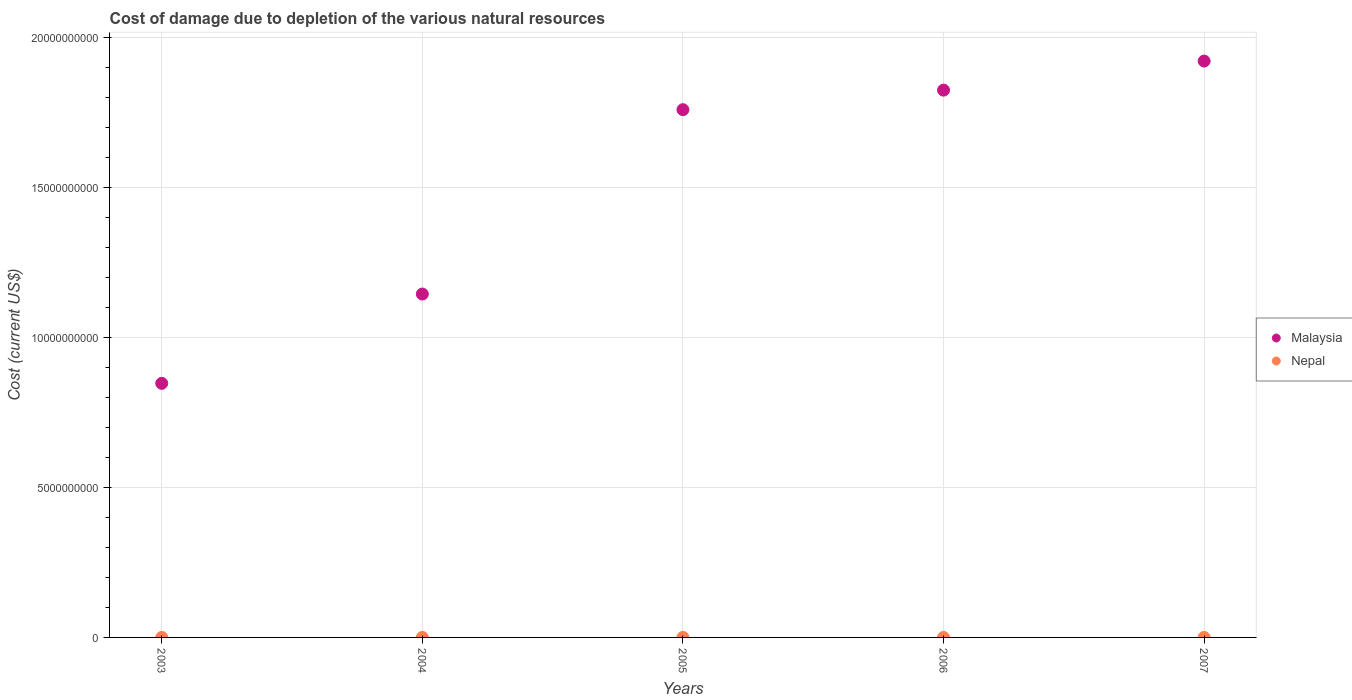How many different coloured dotlines are there?
Provide a succinct answer. 2. Is the number of dotlines equal to the number of legend labels?
Your response must be concise. Yes. What is the cost of damage caused due to the depletion of various natural resources in Malaysia in 2005?
Your answer should be compact. 1.76e+1. Across all years, what is the maximum cost of damage caused due to the depletion of various natural resources in Malaysia?
Your answer should be compact. 1.92e+1. Across all years, what is the minimum cost of damage caused due to the depletion of various natural resources in Malaysia?
Offer a terse response. 8.47e+09. In which year was the cost of damage caused due to the depletion of various natural resources in Malaysia maximum?
Provide a short and direct response. 2007. In which year was the cost of damage caused due to the depletion of various natural resources in Nepal minimum?
Make the answer very short. 2003. What is the total cost of damage caused due to the depletion of various natural resources in Nepal in the graph?
Your answer should be compact. 9.70e+05. What is the difference between the cost of damage caused due to the depletion of various natural resources in Nepal in 2004 and that in 2007?
Offer a terse response. -1.39e+05. What is the difference between the cost of damage caused due to the depletion of various natural resources in Malaysia in 2005 and the cost of damage caused due to the depletion of various natural resources in Nepal in 2007?
Offer a very short reply. 1.76e+1. What is the average cost of damage caused due to the depletion of various natural resources in Malaysia per year?
Make the answer very short. 1.50e+1. In the year 2007, what is the difference between the cost of damage caused due to the depletion of various natural resources in Malaysia and cost of damage caused due to the depletion of various natural resources in Nepal?
Offer a very short reply. 1.92e+1. What is the ratio of the cost of damage caused due to the depletion of various natural resources in Malaysia in 2004 to that in 2005?
Keep it short and to the point. 0.65. Is the difference between the cost of damage caused due to the depletion of various natural resources in Malaysia in 2003 and 2004 greater than the difference between the cost of damage caused due to the depletion of various natural resources in Nepal in 2003 and 2004?
Offer a terse response. No. What is the difference between the highest and the second highest cost of damage caused due to the depletion of various natural resources in Nepal?
Provide a succinct answer. 1.12e+04. What is the difference between the highest and the lowest cost of damage caused due to the depletion of various natural resources in Nepal?
Your answer should be compact. 2.63e+05. Does the cost of damage caused due to the depletion of various natural resources in Nepal monotonically increase over the years?
Offer a very short reply. No. Is the cost of damage caused due to the depletion of various natural resources in Nepal strictly greater than the cost of damage caused due to the depletion of various natural resources in Malaysia over the years?
Your response must be concise. No. Is the cost of damage caused due to the depletion of various natural resources in Malaysia strictly less than the cost of damage caused due to the depletion of various natural resources in Nepal over the years?
Offer a very short reply. No. How many dotlines are there?
Make the answer very short. 2. How many years are there in the graph?
Provide a short and direct response. 5. What is the difference between two consecutive major ticks on the Y-axis?
Make the answer very short. 5.00e+09. Are the values on the major ticks of Y-axis written in scientific E-notation?
Your response must be concise. No. Does the graph contain any zero values?
Offer a terse response. No. Does the graph contain grids?
Make the answer very short. Yes. How many legend labels are there?
Your response must be concise. 2. How are the legend labels stacked?
Your answer should be very brief. Vertical. What is the title of the graph?
Offer a terse response. Cost of damage due to depletion of the various natural resources. Does "Malta" appear as one of the legend labels in the graph?
Make the answer very short. No. What is the label or title of the X-axis?
Your response must be concise. Years. What is the label or title of the Y-axis?
Give a very brief answer. Cost (current US$). What is the Cost (current US$) of Malaysia in 2003?
Keep it short and to the point. 8.47e+09. What is the Cost (current US$) in Nepal in 2003?
Your response must be concise. 4.26e+04. What is the Cost (current US$) of Malaysia in 2004?
Your response must be concise. 1.14e+1. What is the Cost (current US$) of Nepal in 2004?
Offer a terse response. 1.67e+05. What is the Cost (current US$) of Malaysia in 2005?
Ensure brevity in your answer.  1.76e+1. What is the Cost (current US$) of Nepal in 2005?
Provide a short and direct response. 1.60e+05. What is the Cost (current US$) in Malaysia in 2006?
Provide a succinct answer. 1.82e+1. What is the Cost (current US$) of Nepal in 2006?
Keep it short and to the point. 2.95e+05. What is the Cost (current US$) in Malaysia in 2007?
Provide a succinct answer. 1.92e+1. What is the Cost (current US$) in Nepal in 2007?
Your answer should be very brief. 3.06e+05. Across all years, what is the maximum Cost (current US$) of Malaysia?
Your response must be concise. 1.92e+1. Across all years, what is the maximum Cost (current US$) of Nepal?
Provide a short and direct response. 3.06e+05. Across all years, what is the minimum Cost (current US$) of Malaysia?
Offer a terse response. 8.47e+09. Across all years, what is the minimum Cost (current US$) in Nepal?
Your answer should be compact. 4.26e+04. What is the total Cost (current US$) in Malaysia in the graph?
Offer a very short reply. 7.49e+1. What is the total Cost (current US$) of Nepal in the graph?
Make the answer very short. 9.70e+05. What is the difference between the Cost (current US$) in Malaysia in 2003 and that in 2004?
Your response must be concise. -2.98e+09. What is the difference between the Cost (current US$) in Nepal in 2003 and that in 2004?
Keep it short and to the point. -1.24e+05. What is the difference between the Cost (current US$) in Malaysia in 2003 and that in 2005?
Give a very brief answer. -9.12e+09. What is the difference between the Cost (current US$) of Nepal in 2003 and that in 2005?
Make the answer very short. -1.18e+05. What is the difference between the Cost (current US$) of Malaysia in 2003 and that in 2006?
Provide a short and direct response. -9.77e+09. What is the difference between the Cost (current US$) of Nepal in 2003 and that in 2006?
Provide a short and direct response. -2.52e+05. What is the difference between the Cost (current US$) of Malaysia in 2003 and that in 2007?
Give a very brief answer. -1.07e+1. What is the difference between the Cost (current US$) in Nepal in 2003 and that in 2007?
Give a very brief answer. -2.63e+05. What is the difference between the Cost (current US$) of Malaysia in 2004 and that in 2005?
Ensure brevity in your answer.  -6.14e+09. What is the difference between the Cost (current US$) of Nepal in 2004 and that in 2005?
Keep it short and to the point. 6525.26. What is the difference between the Cost (current US$) of Malaysia in 2004 and that in 2006?
Offer a very short reply. -6.79e+09. What is the difference between the Cost (current US$) in Nepal in 2004 and that in 2006?
Provide a succinct answer. -1.28e+05. What is the difference between the Cost (current US$) of Malaysia in 2004 and that in 2007?
Offer a terse response. -7.76e+09. What is the difference between the Cost (current US$) in Nepal in 2004 and that in 2007?
Offer a terse response. -1.39e+05. What is the difference between the Cost (current US$) in Malaysia in 2005 and that in 2006?
Provide a succinct answer. -6.51e+08. What is the difference between the Cost (current US$) of Nepal in 2005 and that in 2006?
Offer a terse response. -1.34e+05. What is the difference between the Cost (current US$) in Malaysia in 2005 and that in 2007?
Offer a very short reply. -1.62e+09. What is the difference between the Cost (current US$) of Nepal in 2005 and that in 2007?
Offer a terse response. -1.45e+05. What is the difference between the Cost (current US$) of Malaysia in 2006 and that in 2007?
Offer a terse response. -9.69e+08. What is the difference between the Cost (current US$) in Nepal in 2006 and that in 2007?
Keep it short and to the point. -1.12e+04. What is the difference between the Cost (current US$) in Malaysia in 2003 and the Cost (current US$) in Nepal in 2004?
Your response must be concise. 8.47e+09. What is the difference between the Cost (current US$) of Malaysia in 2003 and the Cost (current US$) of Nepal in 2005?
Offer a terse response. 8.47e+09. What is the difference between the Cost (current US$) in Malaysia in 2003 and the Cost (current US$) in Nepal in 2006?
Ensure brevity in your answer.  8.47e+09. What is the difference between the Cost (current US$) of Malaysia in 2003 and the Cost (current US$) of Nepal in 2007?
Provide a short and direct response. 8.47e+09. What is the difference between the Cost (current US$) in Malaysia in 2004 and the Cost (current US$) in Nepal in 2005?
Offer a very short reply. 1.14e+1. What is the difference between the Cost (current US$) in Malaysia in 2004 and the Cost (current US$) in Nepal in 2006?
Your answer should be compact. 1.14e+1. What is the difference between the Cost (current US$) in Malaysia in 2004 and the Cost (current US$) in Nepal in 2007?
Offer a terse response. 1.14e+1. What is the difference between the Cost (current US$) of Malaysia in 2005 and the Cost (current US$) of Nepal in 2006?
Give a very brief answer. 1.76e+1. What is the difference between the Cost (current US$) of Malaysia in 2005 and the Cost (current US$) of Nepal in 2007?
Your answer should be compact. 1.76e+1. What is the difference between the Cost (current US$) of Malaysia in 2006 and the Cost (current US$) of Nepal in 2007?
Provide a succinct answer. 1.82e+1. What is the average Cost (current US$) in Malaysia per year?
Ensure brevity in your answer.  1.50e+1. What is the average Cost (current US$) of Nepal per year?
Provide a succinct answer. 1.94e+05. In the year 2003, what is the difference between the Cost (current US$) in Malaysia and Cost (current US$) in Nepal?
Your answer should be very brief. 8.47e+09. In the year 2004, what is the difference between the Cost (current US$) of Malaysia and Cost (current US$) of Nepal?
Provide a succinct answer. 1.14e+1. In the year 2005, what is the difference between the Cost (current US$) in Malaysia and Cost (current US$) in Nepal?
Provide a succinct answer. 1.76e+1. In the year 2006, what is the difference between the Cost (current US$) of Malaysia and Cost (current US$) of Nepal?
Keep it short and to the point. 1.82e+1. In the year 2007, what is the difference between the Cost (current US$) in Malaysia and Cost (current US$) in Nepal?
Your answer should be compact. 1.92e+1. What is the ratio of the Cost (current US$) in Malaysia in 2003 to that in 2004?
Keep it short and to the point. 0.74. What is the ratio of the Cost (current US$) of Nepal in 2003 to that in 2004?
Give a very brief answer. 0.26. What is the ratio of the Cost (current US$) of Malaysia in 2003 to that in 2005?
Provide a succinct answer. 0.48. What is the ratio of the Cost (current US$) in Nepal in 2003 to that in 2005?
Ensure brevity in your answer.  0.27. What is the ratio of the Cost (current US$) in Malaysia in 2003 to that in 2006?
Keep it short and to the point. 0.46. What is the ratio of the Cost (current US$) of Nepal in 2003 to that in 2006?
Give a very brief answer. 0.14. What is the ratio of the Cost (current US$) of Malaysia in 2003 to that in 2007?
Provide a short and direct response. 0.44. What is the ratio of the Cost (current US$) of Nepal in 2003 to that in 2007?
Offer a terse response. 0.14. What is the ratio of the Cost (current US$) of Malaysia in 2004 to that in 2005?
Ensure brevity in your answer.  0.65. What is the ratio of the Cost (current US$) of Nepal in 2004 to that in 2005?
Give a very brief answer. 1.04. What is the ratio of the Cost (current US$) of Malaysia in 2004 to that in 2006?
Your answer should be very brief. 0.63. What is the ratio of the Cost (current US$) in Nepal in 2004 to that in 2006?
Offer a terse response. 0.57. What is the ratio of the Cost (current US$) in Malaysia in 2004 to that in 2007?
Give a very brief answer. 0.6. What is the ratio of the Cost (current US$) of Nepal in 2004 to that in 2007?
Provide a succinct answer. 0.55. What is the ratio of the Cost (current US$) of Malaysia in 2005 to that in 2006?
Offer a terse response. 0.96. What is the ratio of the Cost (current US$) in Nepal in 2005 to that in 2006?
Your answer should be very brief. 0.54. What is the ratio of the Cost (current US$) in Malaysia in 2005 to that in 2007?
Provide a succinct answer. 0.92. What is the ratio of the Cost (current US$) in Nepal in 2005 to that in 2007?
Your answer should be very brief. 0.52. What is the ratio of the Cost (current US$) in Malaysia in 2006 to that in 2007?
Offer a terse response. 0.95. What is the ratio of the Cost (current US$) in Nepal in 2006 to that in 2007?
Provide a succinct answer. 0.96. What is the difference between the highest and the second highest Cost (current US$) in Malaysia?
Give a very brief answer. 9.69e+08. What is the difference between the highest and the second highest Cost (current US$) in Nepal?
Your answer should be very brief. 1.12e+04. What is the difference between the highest and the lowest Cost (current US$) of Malaysia?
Make the answer very short. 1.07e+1. What is the difference between the highest and the lowest Cost (current US$) in Nepal?
Your answer should be very brief. 2.63e+05. 